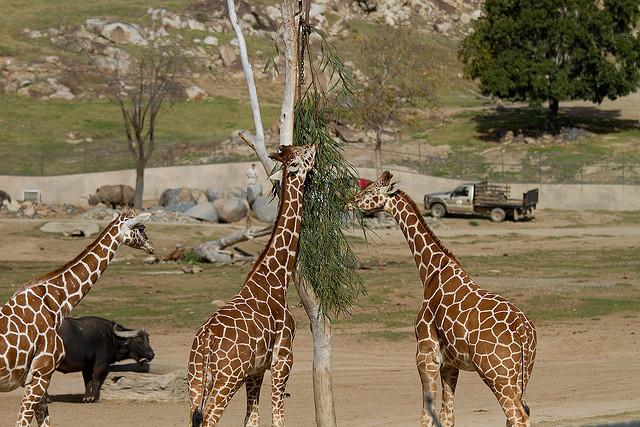Is there a truck in the distance?
Quick response, please. Yes. How old are these giraffes?
Concise answer only. 5 years old. Are more than one types of animal featured in this picture?
Concise answer only. Yes. 